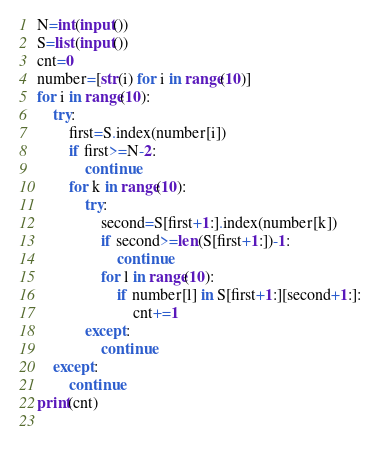<code> <loc_0><loc_0><loc_500><loc_500><_Python_>N=int(input())
S=list(input())
cnt=0
number=[str(i) for i in range(10)]
for i in range(10):
    try:
        first=S.index(number[i])
        if first>=N-2:
            continue
        for k in range(10):
            try:
                second=S[first+1:].index(number[k])
                if second>=len(S[first+1:])-1:
                    continue
                for l in range(10):
                    if number[l] in S[first+1:][second+1:]:
                        cnt+=1
            except:
                continue
    except:
        continue
print(cnt)
                </code> 